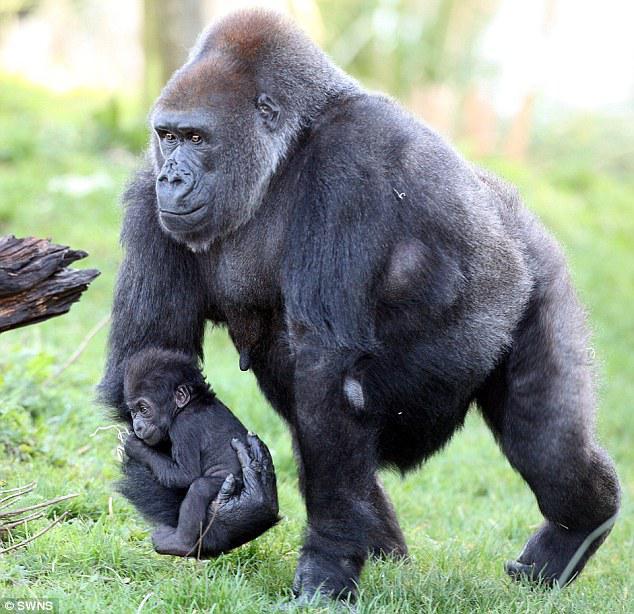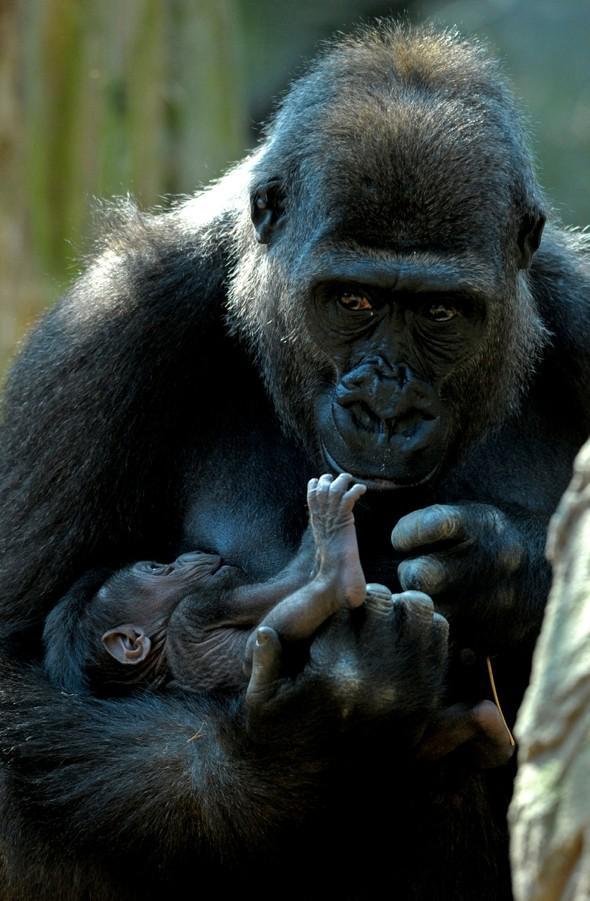The first image is the image on the left, the second image is the image on the right. For the images displayed, is the sentence "The left image shows a baby gorilla clinging to the arm of an adult gorilla, and the right image includes a hand touching a foot." factually correct? Answer yes or no. Yes. The first image is the image on the left, the second image is the image on the right. Examine the images to the left and right. Is the description "A mother gorilla is holding her infant on one arm" accurate? Answer yes or no. Yes. 